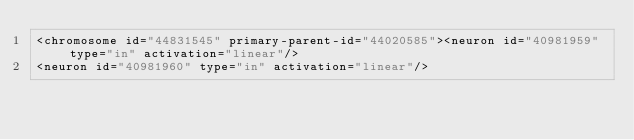<code> <loc_0><loc_0><loc_500><loc_500><_XML_><chromosome id="44831545" primary-parent-id="44020585"><neuron id="40981959" type="in" activation="linear"/>
<neuron id="40981960" type="in" activation="linear"/></code> 